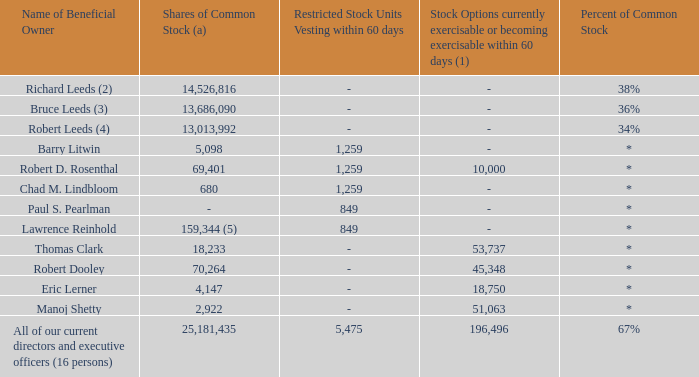Security Ownership of Management
(a) Amounts listed in this column may include shares held in partnerships or trusts that are counted in more than one individual’s total.
* less than 1%
(1) In computing the percentage of shares owned by each person and by the group, these restricted stock units and stock options, as applicable,
were added to the total number of outstanding shares of common stock for the percentage calculation.
(2) Includes 577,462 shares owned by Mr. Richard Leeds directly, 1,000,000 shares owned by the Richard Leeds 2020 GRAT, 1,000,000
shares owned by the Richard Leeds 2019 GRAT, and 1,263,265 shares owned by the Richard Leeds 2018 GRAT. Also, includes 1,838,583
shares owned by a limited partnership of which Mr. Richard Leeds is a general partner, 100 shares owned by the general partner of the
aforementioned limited partnership, 235,850 shares owned by a limited partnership of which a limited liability company controlled by Mr.
Richard Leeds is the general partner, 7,981,756 shares owned by trusts for the benefit of his brothers’ children for which Mr. Richard Leeds
acts as co-trustee, 519,800 shares owned by a limited partnership in which Mr. Richard Leeds has an indirect pecuniary interest, and
10,000 shares owned by trusts for the benefits of other family members for which Mr. Richard Leeds acts as co-trustee.
(3) Includes 1,007,661 shares owned by Mr. Bruce Leeds directly, 1,000,000 shares owned by the Bruce Leeds 2020 GRAT, 1,000,000 shares
owned by the Bruce Leeds 2019 GRAT, and 581,633 shares owned by the Bruce Leeds 2018 GRAT. Also, includes 1,838,583 shares
owned by a limited partnership of which Mr. Bruce Leeds is a general partner, 100 shares owned by the general partner of the aforementioned
limited partnership, 7,728,313 shares owned by trusts for the benefit of his brothers’ children for which Mr. Bruce Leeds acts as co-trustee,
519,800 shares owned by a limited partnership in which Mr. Bruce Leeds has an indirect pecuniary interest, and 10,000 shares owned by
trusts for the benefits of other family members for which Mr. Richard Leeds acts as co-trustee.
(4) Includes 16,429 shares owned by Mr. Robert Leeds directly, 1,000,000 shares owned by the Robert Leeds 2020 GRAT, 1,500,000 shares
owned by the Robert Leeds 2019 GRAT, and 741,817 shares owned by the Robert Leeds 2018 GRAT. Also, includes 1,838,583 shares
owned by a limited partnership of which Mr. Robert Leeds is a general partner, 100 shares owned by the general partner of the aforementioned
limited partnership, 7,397,263 shares owned by trusts for the benefit of his brothers’ children for which Mr. Robert Leeds acts as co-trustee
and 519,800 shares owned by a limited partnership in which Mr. Robert Leeds has an indirect pecuniary interest.
(5) Includes 1,000 shares held by Mr. Reinhold's spouse, of which Mr. Reinhold disclaims beneficial ownership.
What is the percent of common stock owned by Richard Leeds and Bruce Leeds? 38%, 36%. How many shares of common stock are owned by Richard Leeds and Bruce Leeds? 14,526,816, 13,686,090. What is the percent of common stock owned by Barry Litwin and Robert D. Rosenthal? Less than 1%, less than 1%. What is the total shares of common stock owned by the top three shareholders of the company? 14,526,816 + 13,686,090 + 13,013,992 
Answer: 41226898. What percentage of the total restricted stock units vesting within 60 days are owned by Barry Litwin? 
Answer scale should be: percent. 1,259/5,475 
Answer: 23. What percentage of Lawrence Reinhold's shares of common stock is owned by his spouse?
Answer scale should be: percent. 1,000/159,344 
Answer: 0.63. 